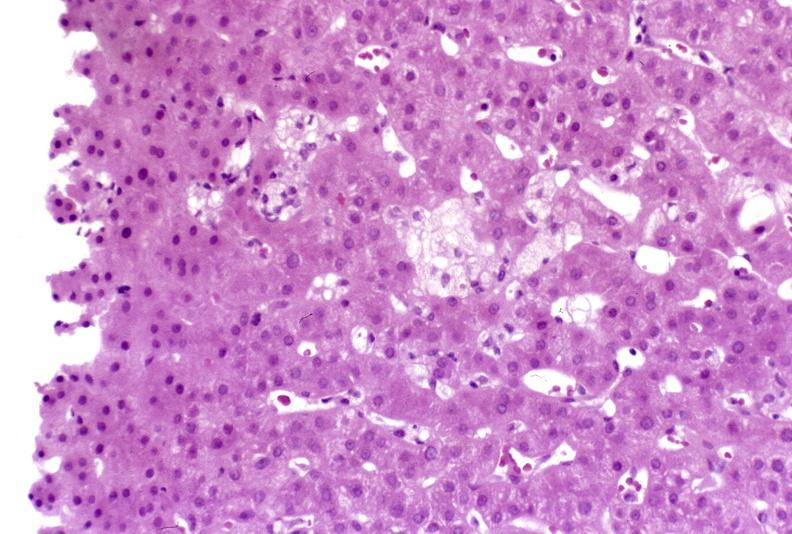what is present?
Answer the question using a single word or phrase. Hepatobiliary 